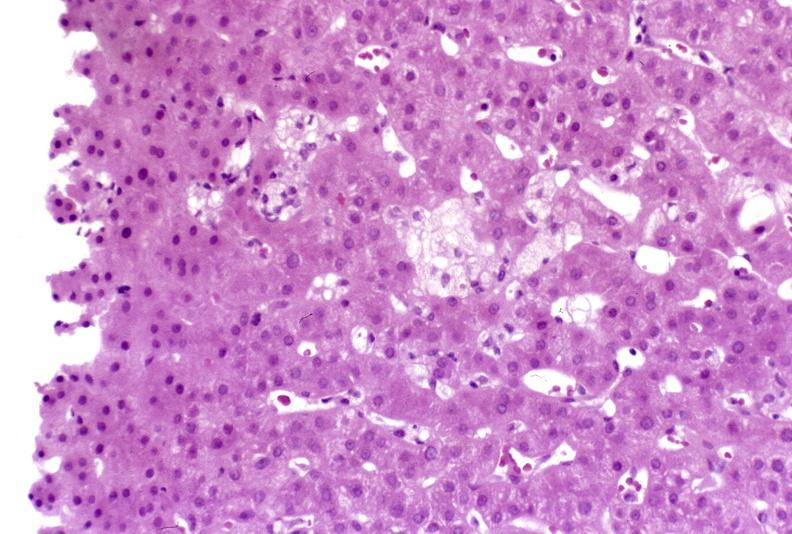what is present?
Answer the question using a single word or phrase. Hepatobiliary 